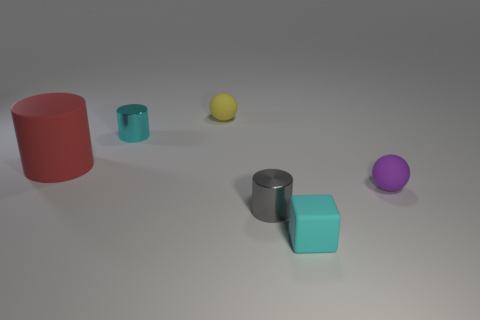Add 3 large red cylinders. How many objects exist? 9 Subtract all balls. How many objects are left? 4 Subtract 0 gray balls. How many objects are left? 6 Subtract all large gray spheres. Subtract all purple objects. How many objects are left? 5 Add 4 small matte cubes. How many small matte cubes are left? 5 Add 3 tiny cyan cylinders. How many tiny cyan cylinders exist? 4 